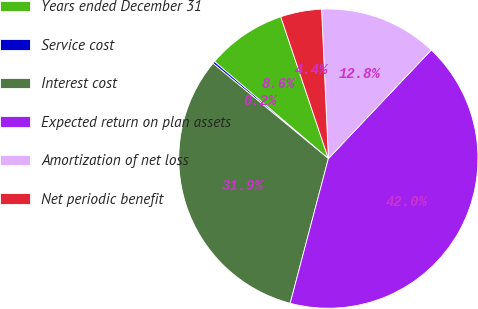Convert chart. <chart><loc_0><loc_0><loc_500><loc_500><pie_chart><fcel>Years ended December 31<fcel>Service cost<fcel>Interest cost<fcel>Expected return on plan assets<fcel>Amortization of net loss<fcel>Net periodic benefit<nl><fcel>8.61%<fcel>0.25%<fcel>31.88%<fcel>42.04%<fcel>12.79%<fcel>4.43%<nl></chart> 